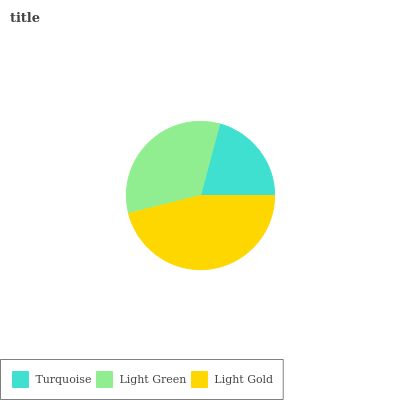Is Turquoise the minimum?
Answer yes or no. Yes. Is Light Gold the maximum?
Answer yes or no. Yes. Is Light Green the minimum?
Answer yes or no. No. Is Light Green the maximum?
Answer yes or no. No. Is Light Green greater than Turquoise?
Answer yes or no. Yes. Is Turquoise less than Light Green?
Answer yes or no. Yes. Is Turquoise greater than Light Green?
Answer yes or no. No. Is Light Green less than Turquoise?
Answer yes or no. No. Is Light Green the high median?
Answer yes or no. Yes. Is Light Green the low median?
Answer yes or no. Yes. Is Light Gold the high median?
Answer yes or no. No. Is Turquoise the low median?
Answer yes or no. No. 